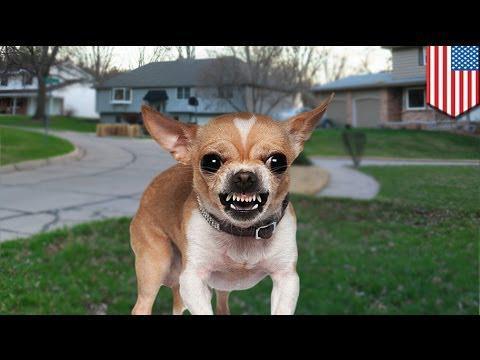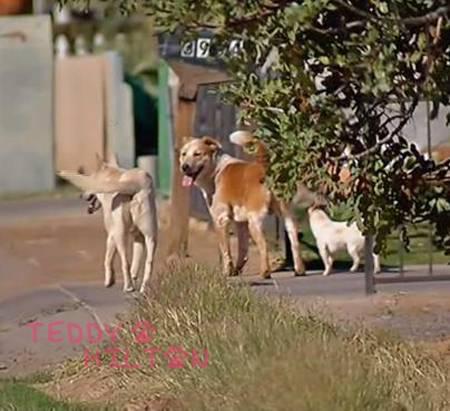The first image is the image on the left, the second image is the image on the right. Considering the images on both sides, is "In one image, chihuahuas are arranged in a horizontal line with a gray cat toward the middle of the row." valid? Answer yes or no. No. The first image is the image on the left, the second image is the image on the right. Assess this claim about the two images: "At least one dog is wearing a red shirt.". Correct or not? Answer yes or no. No. 